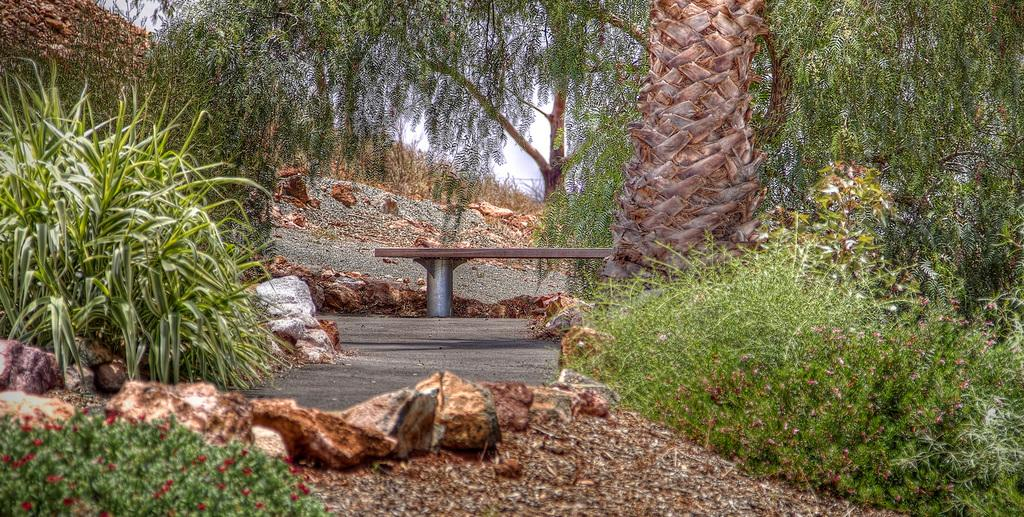What type of surface can be seen in the image? There is ground visible in the image. What is present on the ground? There are objects on the ground, including stones and a bench. What type of vegetation is in the image? There are plants and trees in the image. Can you describe the tree trunk visible in the image? The trunk of a tree is visible in the image. What else can be seen in the sky in the image? The sky is visible in the image, but no specific details about the sky are mentioned in the facts. What type of sweater is the tree wearing in the image? There is no sweater present in the image, as trees do not wear clothing. 